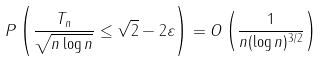<formula> <loc_0><loc_0><loc_500><loc_500>P \left ( \frac { T _ { n } } { \sqrt { n \log n } } \leq \sqrt { 2 } - 2 \varepsilon \right ) = O \left ( \frac { 1 } { n ( \log n ) ^ { 3 / 2 } } \right )</formula> 